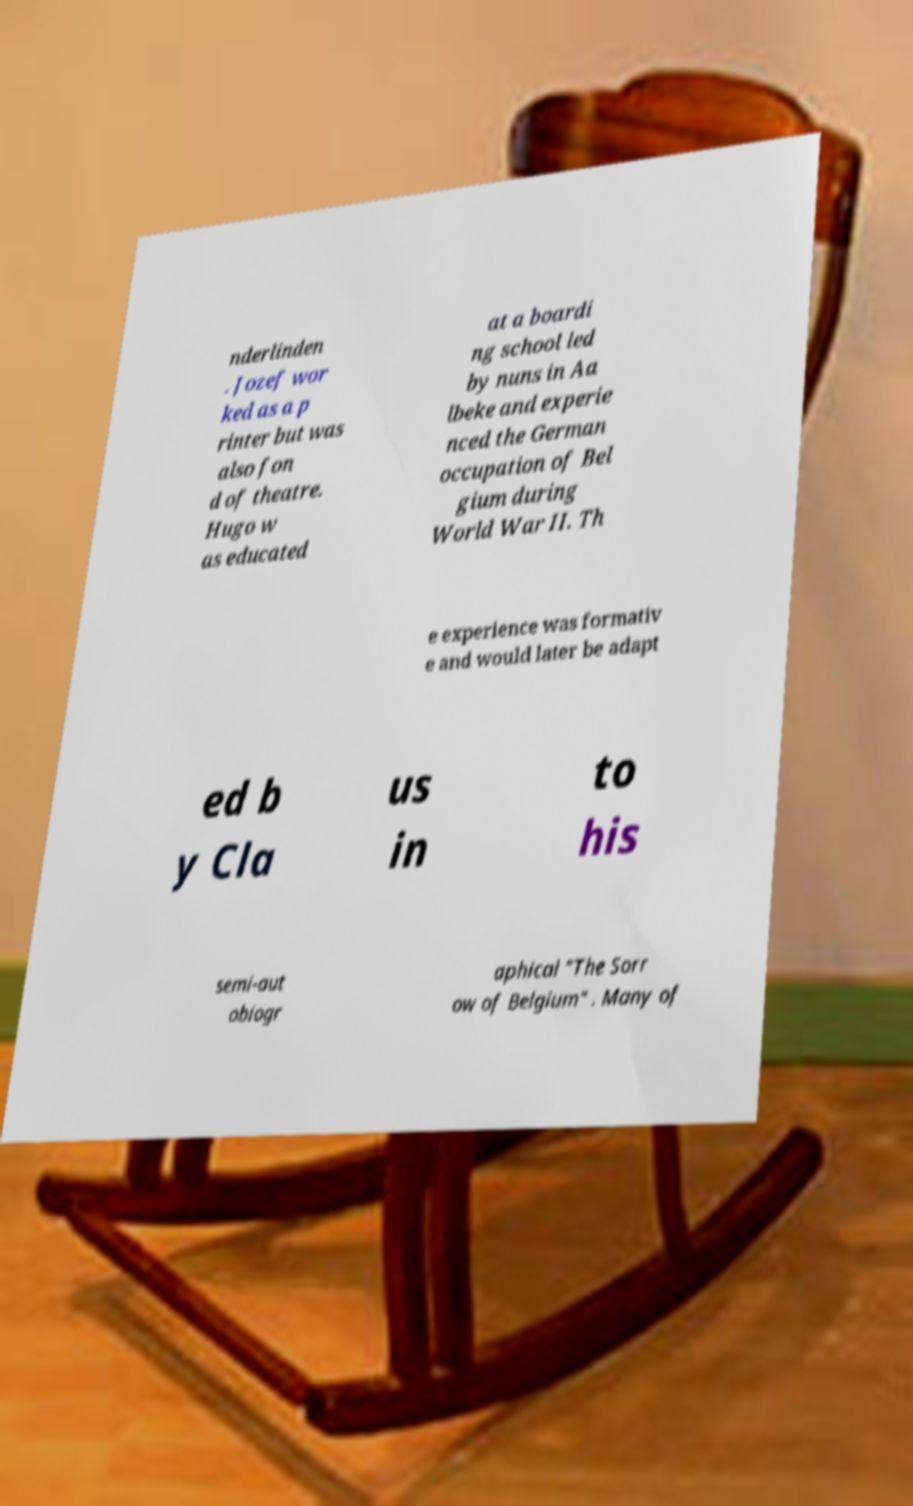Could you extract and type out the text from this image? nderlinden . Jozef wor ked as a p rinter but was also fon d of theatre. Hugo w as educated at a boardi ng school led by nuns in Aa lbeke and experie nced the German occupation of Bel gium during World War II. Th e experience was formativ e and would later be adapt ed b y Cla us in to his semi-aut obiogr aphical "The Sorr ow of Belgium" . Many of 